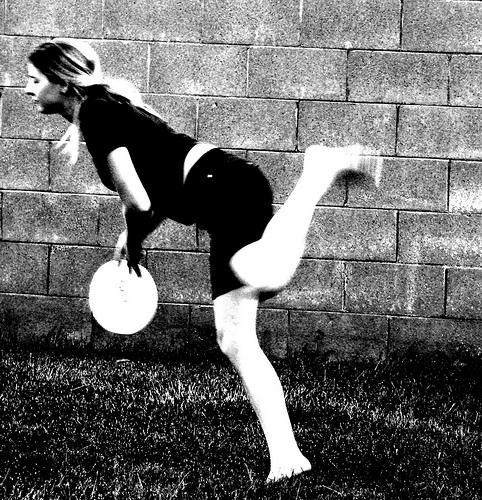Assuming this image was used for a frisbee advertisement, describe the frisbee and its potential player. Catch the ultimate excitement with our sleek white frisbee, perfect for active women with a passion for the sport – whether they have long blonde hair or not! For the visual entailment task, state if the following statement is true or false: "The woman has dark skin." False, the woman is light-skinned. Identify the primary action of the woman in the image. The woman is in a running position, holding a white frisbee, and has one leg bent upward off the ground. Select the correct statement: the woman has a brown or blonde long hair in a ponytail. The woman has long blonde hair in a ponytail. For the referential expression grounding task, determine the object based on the description: a small spot on dark fabric. Small spot on the woman's black shorts. Mention the color and type of frisbee the woman is holding. The woman is holding a white frisbee. Explain what is behind the woman in the picture. There is a cement block wall with square tiles behind the woman, partially covered by grass on the ground. What is under the woman's feet? The woman is standing on short grass on the ground. Describe the clothing the woman is wearing. She is wearing a black short sleeve shirt and black shorts. Is there a bird flying over the woman's head? No, it's not mentioned in the image. Can you see a man sitting on the brick wall? The image shows a woman holding a frisbee, but there is no mention of a man sitting on the brick wall. 